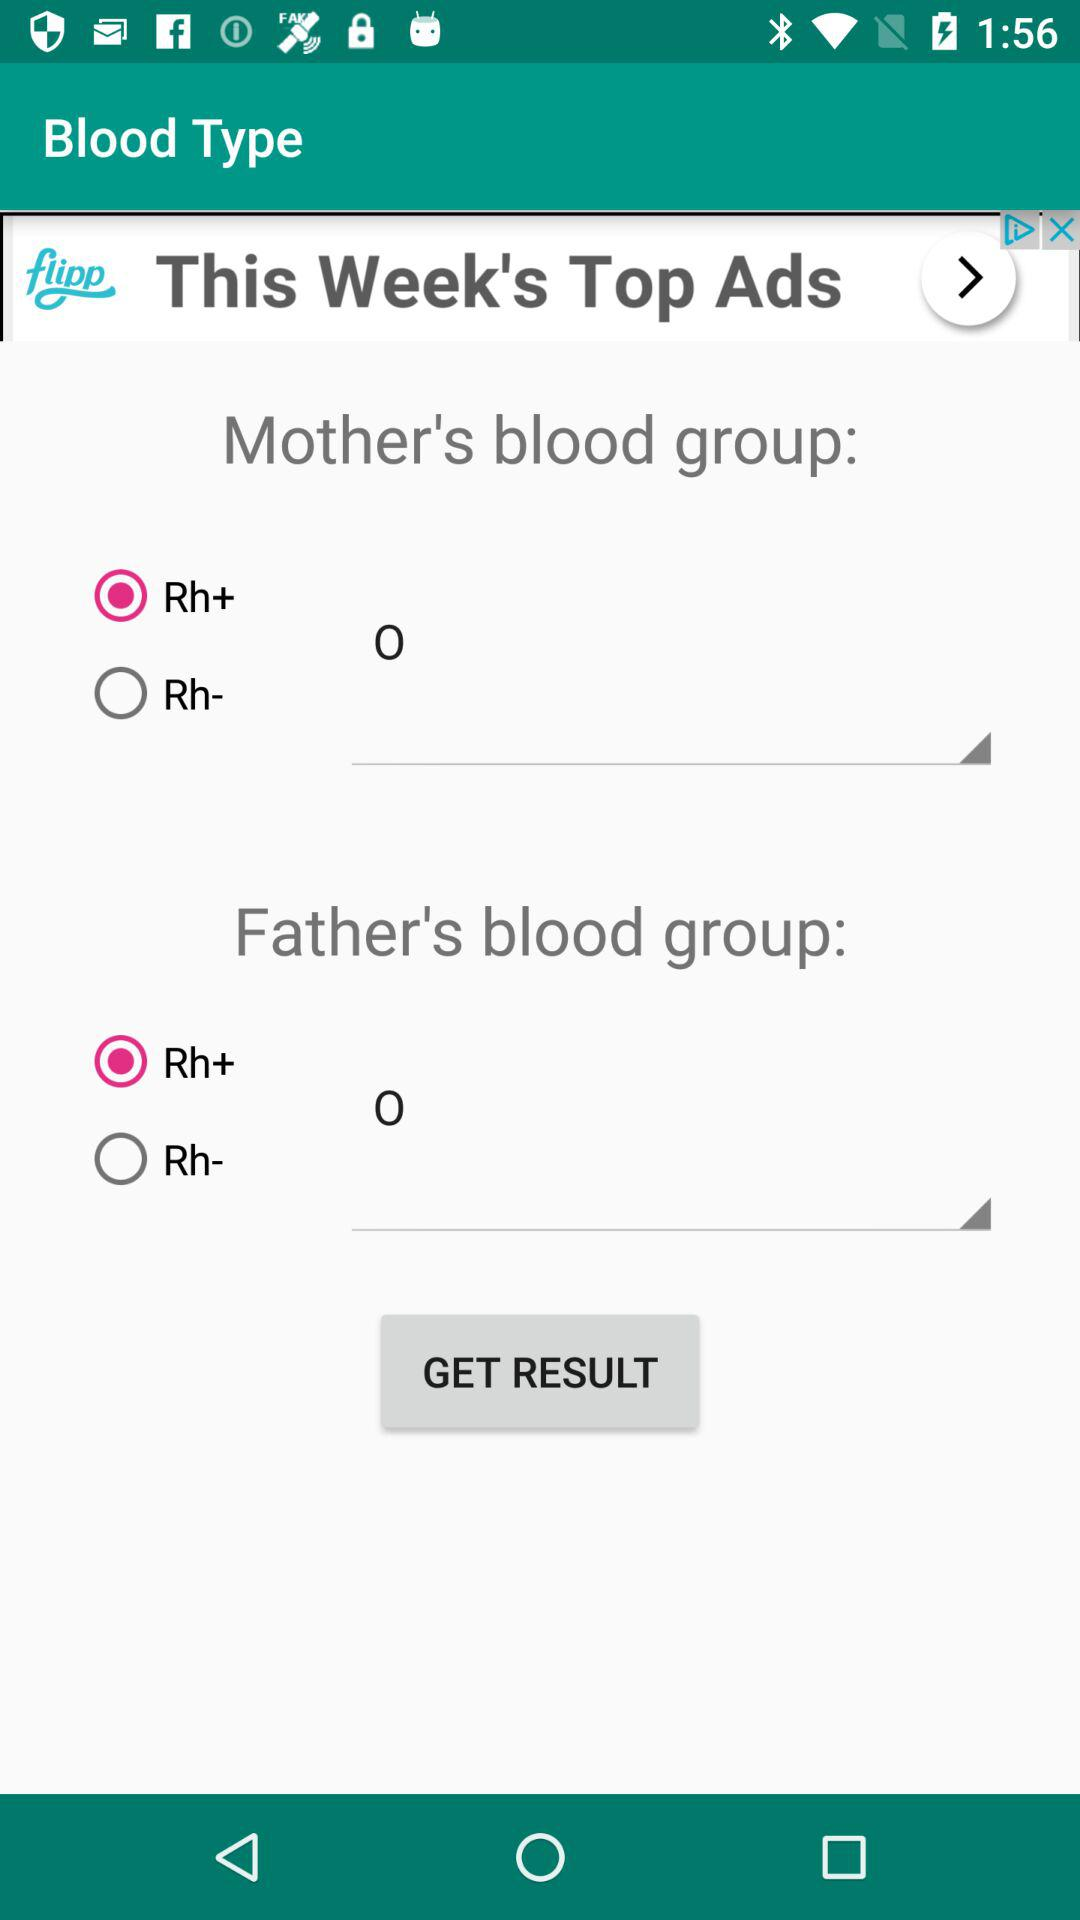Which blood group is the child?
When the provided information is insufficient, respond with <no answer>. <no answer> 